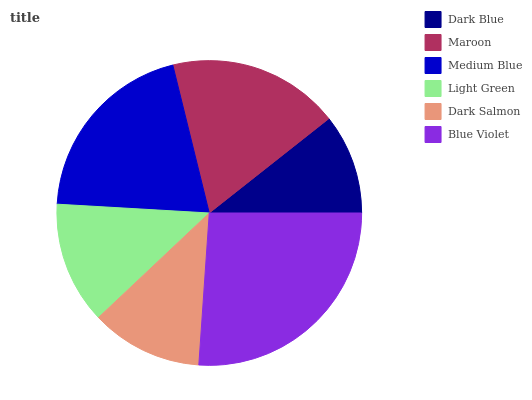Is Dark Blue the minimum?
Answer yes or no. Yes. Is Blue Violet the maximum?
Answer yes or no. Yes. Is Maroon the minimum?
Answer yes or no. No. Is Maroon the maximum?
Answer yes or no. No. Is Maroon greater than Dark Blue?
Answer yes or no. Yes. Is Dark Blue less than Maroon?
Answer yes or no. Yes. Is Dark Blue greater than Maroon?
Answer yes or no. No. Is Maroon less than Dark Blue?
Answer yes or no. No. Is Maroon the high median?
Answer yes or no. Yes. Is Light Green the low median?
Answer yes or no. Yes. Is Dark Blue the high median?
Answer yes or no. No. Is Dark Blue the low median?
Answer yes or no. No. 